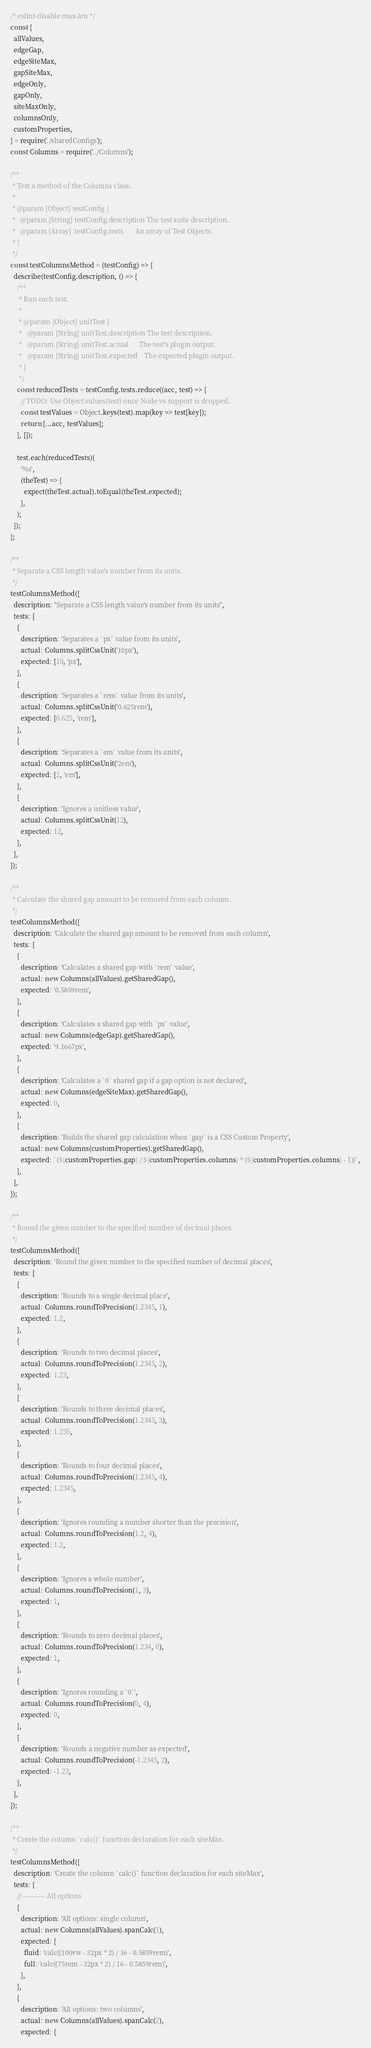Convert code to text. <code><loc_0><loc_0><loc_500><loc_500><_JavaScript_>/* eslint-disable max-len */
const {
  allValues,
  edgeGap,
  edgeSiteMax,
  gapSiteMax,
  edgeOnly,
  gapOnly,
  siteMaxOnly,
  columnsOnly,
  customProperties,
} = require('./sharedConfigs');
const Columns = require('../Columns');

/**
 * Test a method of the Columns class.
 *
 * @param {Object} testConfig {
 *   @param {String} testConfig.description The test suite description.
 *   @param {Array}  testConfig.tests       An array of Test Objects
 * }
 */
const testColumnsMethod = (testConfig) => {
  describe(testConfig.description, () => {
    /**
     * Run each test.
     *
     * @param {Object} unitTest {
     *   @param {String} unitTest.description The test description.
     *   @param {String} unitTest.actual      The test's plugin output.
     *   @param {String} unitTest.expected    The expected plugin output.
     * }
     */
    const reducedTests = testConfig.tests.reduce((acc, test) => {
      // TODO: Use Object.values(test) once Node v6 support is dropped.
      const testValues = Object.keys(test).map(key => test[key]);
      return [...acc, testValues];
    }, []);

    test.each(reducedTests)(
      '%s',
      (theTest) => {
        expect(theTest.actual).toEqual(theTest.expected);
      },
    );
  });
};

/**
 * Separate a CSS length value's number from its units.
 */
testColumnsMethod({
  description: "Separate a CSS length value's number from its units",
  tests: [
    {
      description: 'Separates a `px` value from its units',
      actual: Columns.splitCssUnit('10px'),
      expected: [10, 'px'],
    },
    {
      description: 'Separates a `rem` value from its units',
      actual: Columns.splitCssUnit('0.625rem'),
      expected: [0.625, 'rem'],
    },
    {
      description: 'Separates a `em` value from its units',
      actual: Columns.splitCssUnit('2em'),
      expected: [2, 'em'],
    },
    {
      description: 'Ignores a unitless value',
      actual: Columns.splitCssUnit(12),
      expected: 12,
    },
  ],
});

/**
 * Calculate the shared gap amount to be removed from each column.
 */
testColumnsMethod({
  description: 'Calculate the shared gap amount to be removed from each column',
  tests: [
    {
      description: 'Calculates a shared gap with `rem` value',
      actual: new Columns(allValues).getSharedGap(),
      expected: '0.5859rem',
    },
    {
      description: 'Calculates a shared gap with `px` value',
      actual: new Columns(edgeGap).getSharedGap(),
      expected: '9.1667px',
    },
    {
      description: 'Calculates a `0` shared gap if a gap option is not declared',
      actual: new Columns(edgeSiteMax).getSharedGap(),
      expected: 0,
    },
    {
      description: 'Builds the shared gap calculation when `gap` is a CSS Custom Property',
      actual: new Columns(customProperties).getSharedGap(),
      expected: `(${customProperties.gap} / ${customProperties.columns} * (${customProperties.columns} - 1))`,
    },
  ],
});

/**
 * Round the given number to the specified number of decimal places.
 */
testColumnsMethod({
  description: 'Round the given number to the specified number of decimal places',
  tests: [
    {
      description: 'Rounds to a single decimal place',
      actual: Columns.roundToPrecision(1.2345, 1),
      expected: 1.2,
    },
    {
      description: 'Rounds to two decimal places',
      actual: Columns.roundToPrecision(1.2345, 2),
      expected: 1.23,
    },
    {
      description: 'Rounds to three decimal places',
      actual: Columns.roundToPrecision(1.2345, 3),
      expected: 1.235,
    },
    {
      description: 'Rounds to four decimal places',
      actual: Columns.roundToPrecision(1.2345, 4),
      expected: 1.2345,
    },
    {
      description: 'Ignores rounding a number shorter than the precision',
      actual: Columns.roundToPrecision(1.2, 4),
      expected: 1.2,
    },
    {
      description: 'Ignores a whole number',
      actual: Columns.roundToPrecision(1, 3),
      expected: 1,
    },
    {
      description: 'Rounds to zero decimal places',
      actual: Columns.roundToPrecision(1.234, 0),
      expected: 1,
    },
    {
      description: 'Ignores rounding a `0`',
      actual: Columns.roundToPrecision(0, 4),
      expected: 0,
    },
    {
      description: 'Rounds a negative number as expected',
      actual: Columns.roundToPrecision(-1.2345, 2),
      expected: -1.23,
    },
  ],
});

/**
 * Create the column `calc()` function declaration for each siteMax.
 */
testColumnsMethod({
  description: 'Create the column `calc()` function declaration for each siteMax',
  tests: [
    // ---------- All options
    {
      description: 'All options: single column',
      actual: new Columns(allValues).spanCalc(1),
      expected: {
        fluid: 'calc((100vw - 32px * 2) / 16 - 0.5859rem)',
        full: 'calc((75rem - 32px * 2) / 16 - 0.5859rem)',
      },
    },
    {
      description: 'All options: two columns',
      actual: new Columns(allValues).spanCalc(2),
      expected: {</code> 